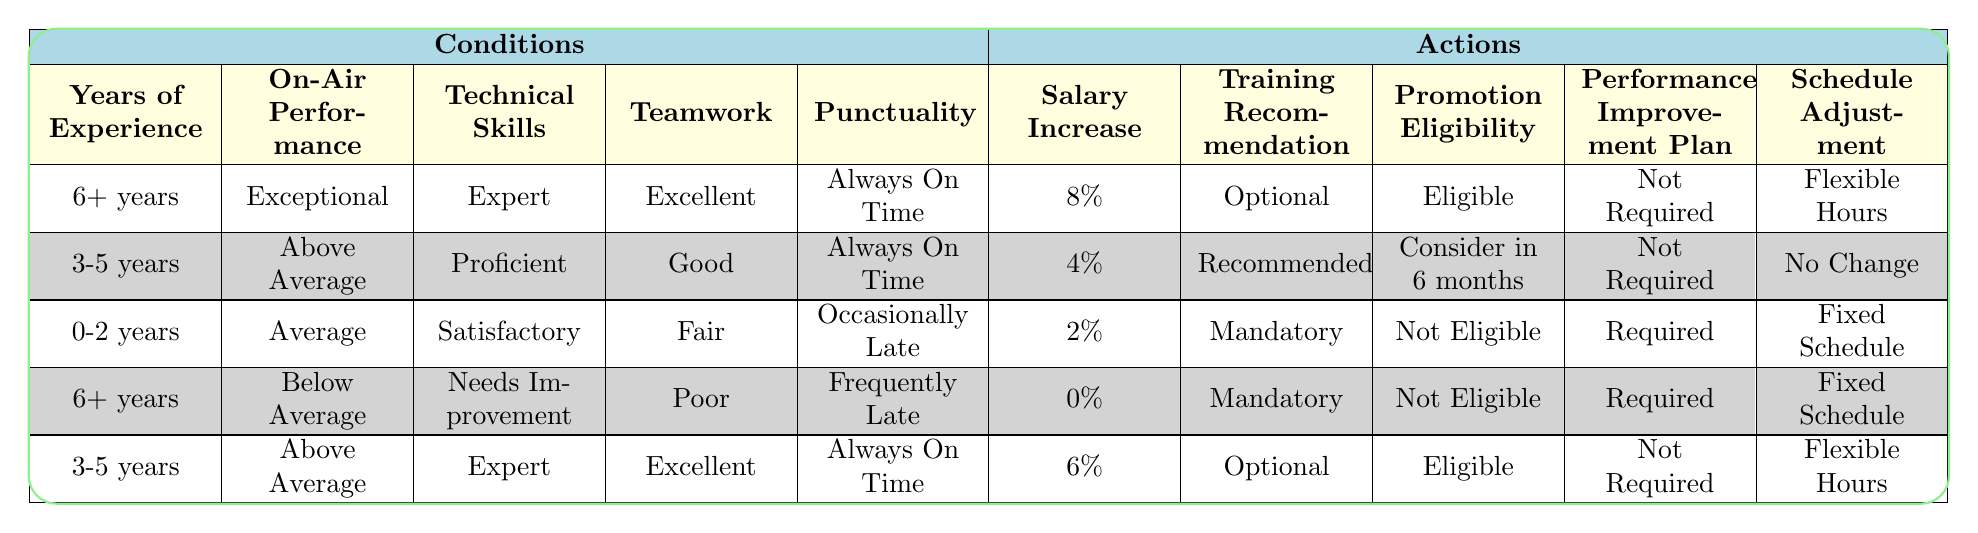What is the salary increase for an employee with 6+ years of experience, exceptional on-air performance, expert technical skills, excellent teamwork, and always on time? Looking at the first row of the table, the conditions matched are: 6+ years, exceptional performance, expert skills, excellent teamwork, and punctuality. The corresponding action for salary increase is 8%.
Answer: 8% Are employees with below average on-air performance eligible for a promotion? In the fourth row, an employee with 6+ years of experience and below average on-air performance is marked as not eligible for promotion.
Answer: No How many actions recommend training as mandatory for employees with 0-2 years of experience? In the third row, the training recommendation for an employee with 0-2 years of experience is mandatory. Meanwhile, in the fourth row, an employee with 6+ years has mandatory training due to poor performance. Therefore, there are 2 actions recommending mandatory training.
Answer: 2 What is the combination of salary increase and training recommendation for someone with 3-5 years of experience, above average on-air performance, proficient technical skills, good teamwork, and always on time? The second row matches these criteria, showing a salary increase of 4% and a training recommendation of recommended.
Answer: 4% and recommended Is there any condition where an employee is eligible for a promotion but requires a performance improvement plan? After checking each row, none has both eligible for promotion and requires a performance improvement plan. Instead, those eligible do not have a required performance improvement plan.
Answer: No What is the average salary increase for employees with 3-5 years of experience? The rows corresponding to 3-5 years show salary increases of 4% and 6%. To find the average: (4% + 6%) / 2 = 5%.
Answer: 5% If an employee is frequently late and has poor teamwork, what is the recommended training for them? Referring to the fourth row, the employee meets the conditions of being frequently late and having poor teamwork, which indicates a mandatory training recommendation.
Answer: Mandatory What is the schedule adjustment for someone with 0-2 years of experience, average performance, satisfactory technical skills, fair teamwork, and occasionally late? In the third row, the matched conditions yield a schedule adjustment of fixed schedule.
Answer: Fixed schedule 